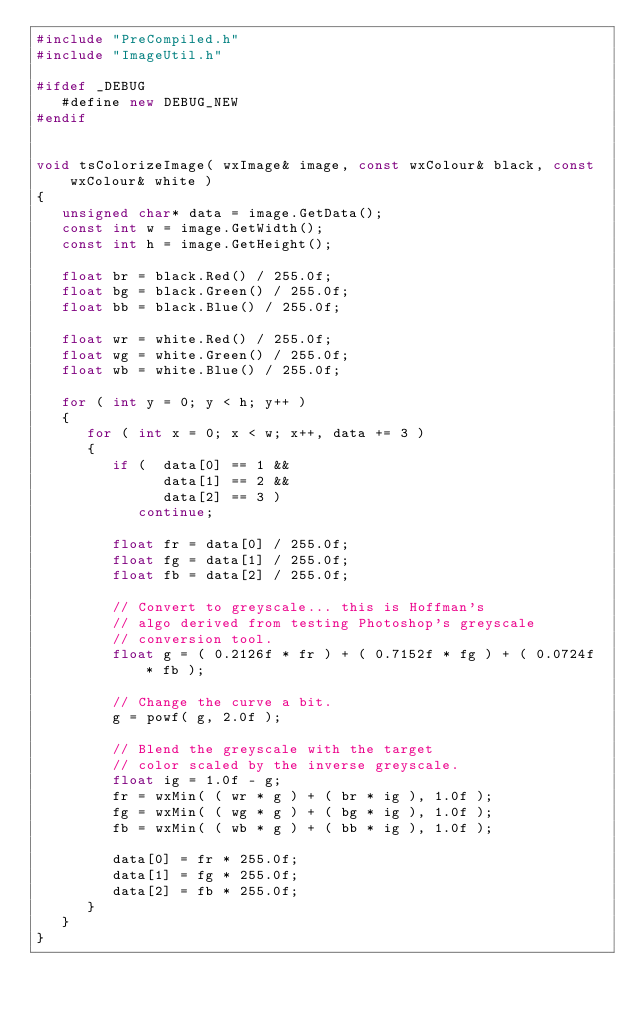<code> <loc_0><loc_0><loc_500><loc_500><_C++_>#include "PreCompiled.h"
#include "ImageUtil.h"

#ifdef _DEBUG 
   #define new DEBUG_NEW 
#endif 


void tsColorizeImage( wxImage& image, const wxColour& black, const wxColour& white )
{
   unsigned char* data = image.GetData();
   const int w = image.GetWidth();
   const int h = image.GetHeight();
   
   float br = black.Red() / 255.0f;
   float bg = black.Green() / 255.0f;
   float bb = black.Blue() / 255.0f;

   float wr = white.Red() / 255.0f;
   float wg = white.Green() / 255.0f;
   float wb = white.Blue() / 255.0f;

   for ( int y = 0; y < h; y++ )
   {
      for ( int x = 0; x < w; x++, data += 3 )
      {
         if (  data[0] == 1 &&
               data[1] == 2 &&
               data[2] == 3 )
            continue;

         float fr = data[0] / 255.0f;
         float fg = data[1] / 255.0f;
         float fb = data[2] / 255.0f;

         // Convert to greyscale... this is Hoffman's
         // algo derived from testing Photoshop's greyscale
         // conversion tool.
         float g = ( 0.2126f * fr ) + ( 0.7152f * fg ) + ( 0.0724f * fb );

         // Change the curve a bit.
         g = powf( g, 2.0f );

         // Blend the greyscale with the target 
         // color scaled by the inverse greyscale.
         float ig = 1.0f - g;
         fr = wxMin( ( wr * g ) + ( br * ig ), 1.0f );
         fg = wxMin( ( wg * g ) + ( bg * ig ), 1.0f );
         fb = wxMin( ( wb * g ) + ( bb * ig ), 1.0f );

         data[0] = fr * 255.0f;
         data[1] = fg * 255.0f;
         data[2] = fb * 255.0f;
      }
   }
}



</code> 